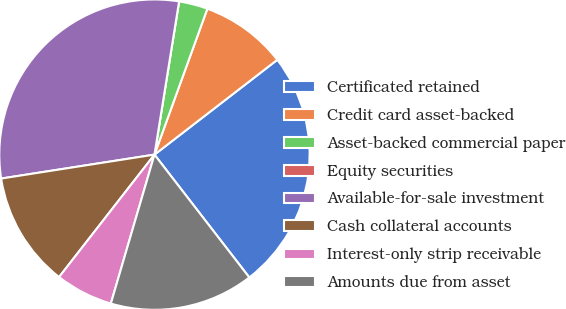Convert chart to OTSL. <chart><loc_0><loc_0><loc_500><loc_500><pie_chart><fcel>Certificated retained<fcel>Credit card asset-backed<fcel>Asset-backed commercial paper<fcel>Equity securities<fcel>Available-for-sale investment<fcel>Cash collateral accounts<fcel>Interest-only strip receivable<fcel>Amounts due from asset<nl><fcel>25.0%<fcel>9.0%<fcel>3.0%<fcel>0.0%<fcel>30.0%<fcel>12.0%<fcel>6.0%<fcel>15.0%<nl></chart> 